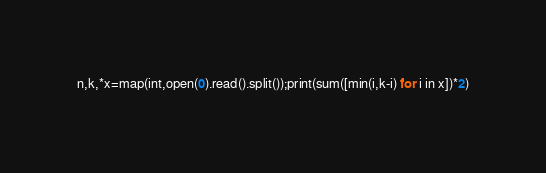<code> <loc_0><loc_0><loc_500><loc_500><_Python_>n,k,*x=map(int,open(0).read().split());print(sum([min(i,k-i) for i in x])*2)</code> 